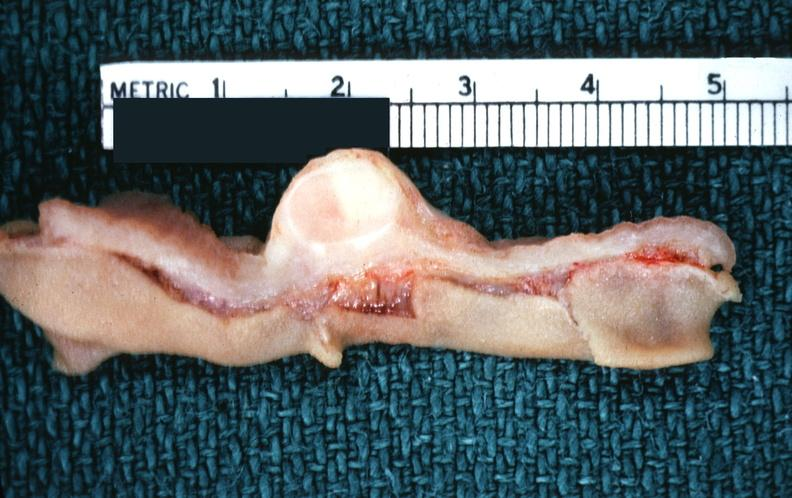does subdiaphragmatic abscess show stomach, leiomyoma with ulcerated mucosal surface?
Answer the question using a single word or phrase. No 